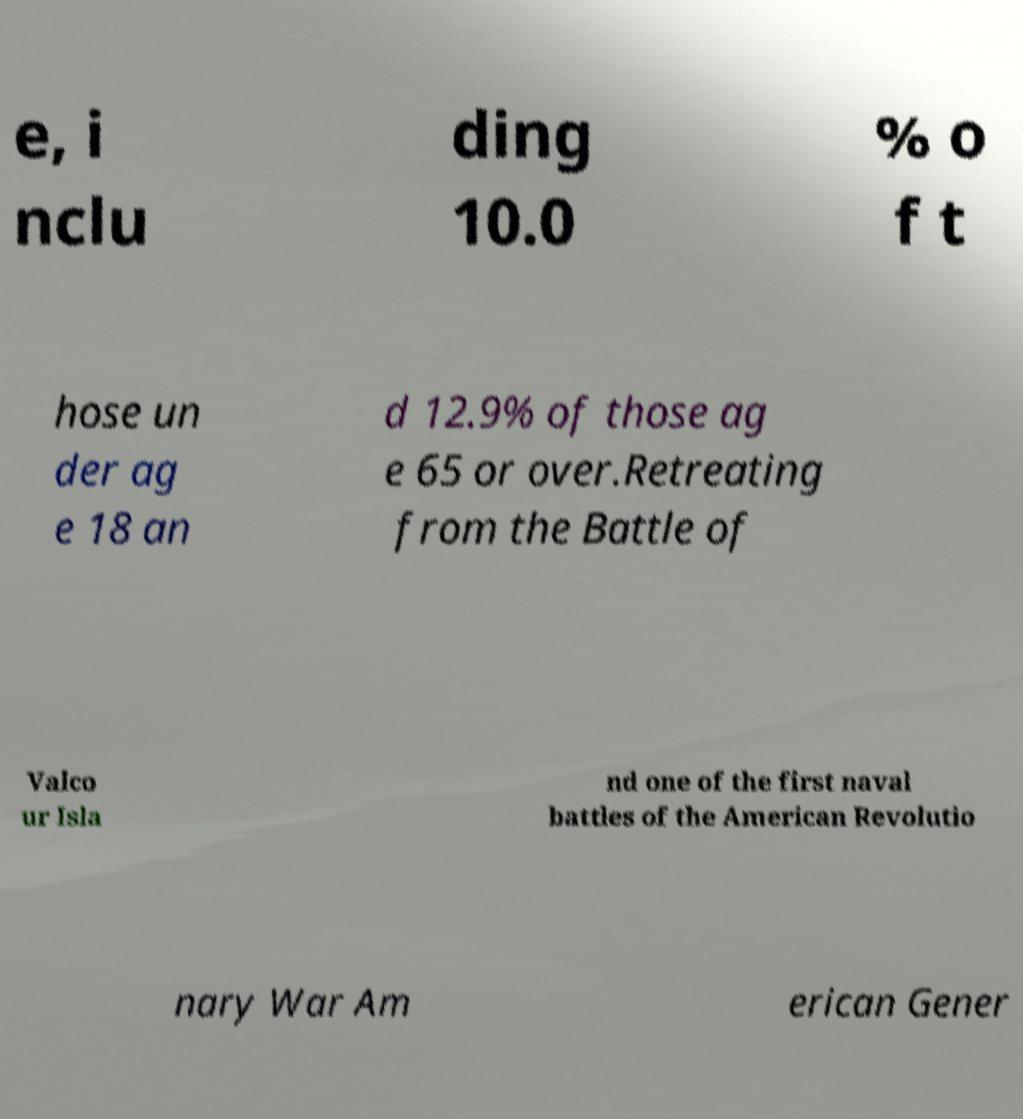What messages or text are displayed in this image? I need them in a readable, typed format. e, i nclu ding 10.0 % o f t hose un der ag e 18 an d 12.9% of those ag e 65 or over.Retreating from the Battle of Valco ur Isla nd one of the first naval battles of the American Revolutio nary War Am erican Gener 